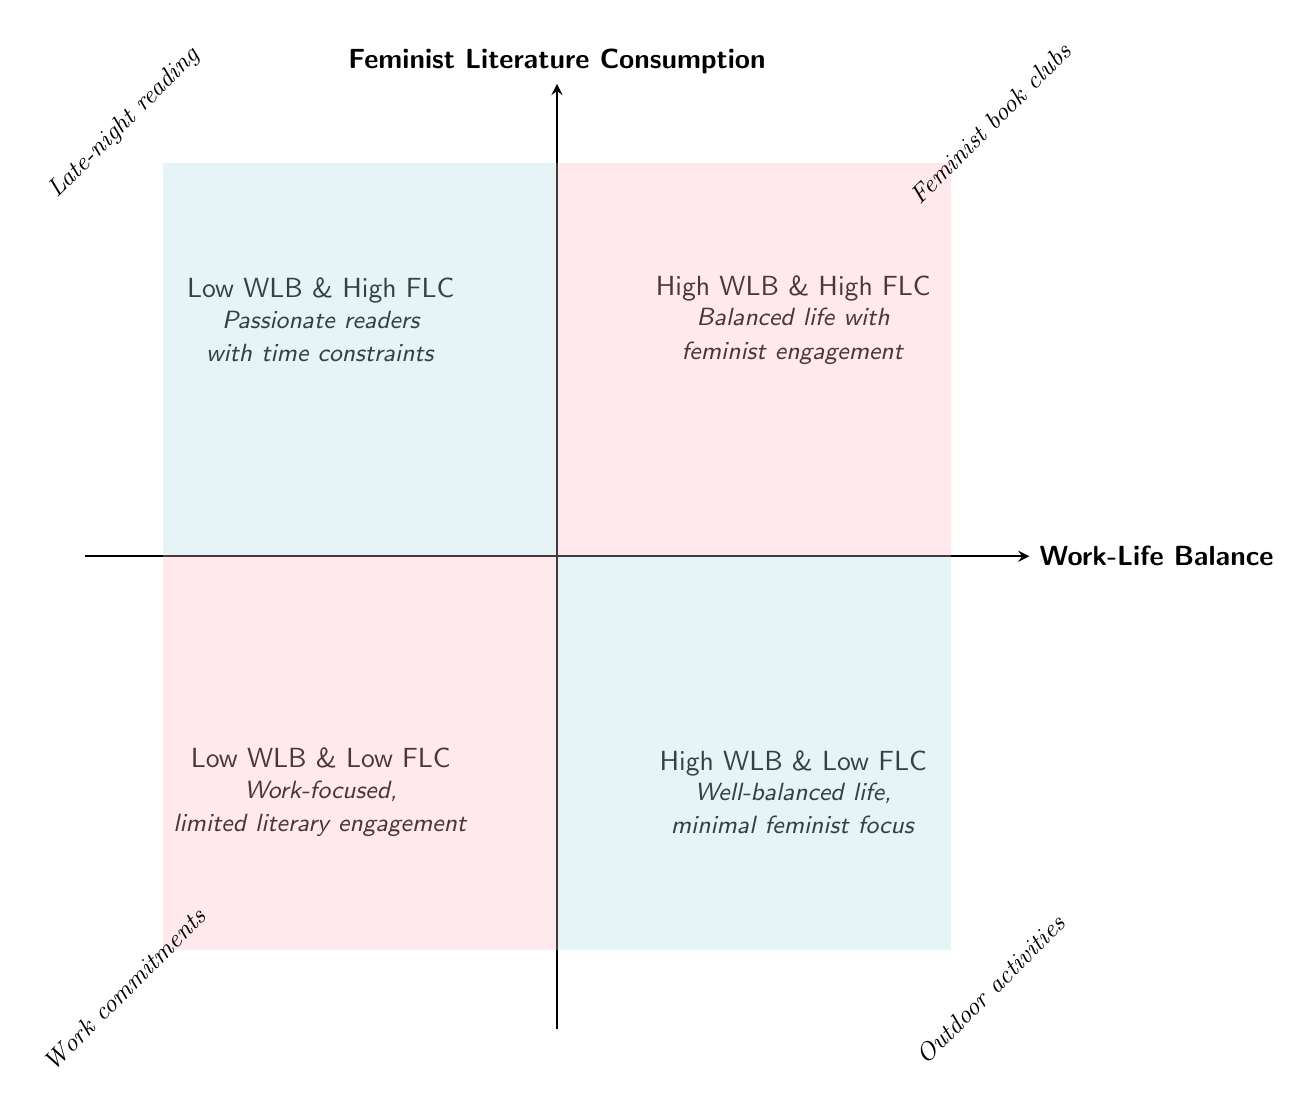What quadrant represents individuals with both high work-life balance and high feminist literature consumption? The top right quadrant represents individuals who are engaged in both aspects—high work-life balance and high feminist literature consumption.
Answer: High WLB & High FLC How many quadrants are represented in this diagram? The diagram is divided into four distinct quadrants, each depicting different combinations of work-life balance and feminist literature consumption.
Answer: Four What is a characteristic of individuals in the low work-life balance and high feminist literature consumption quadrant? Individuals in this quadrant often read feminist literature late at night, indicating they prioritize feminist literature despite poor work-life balance.
Answer: Late-night reading Which quadrant describes individuals who have minimal engagement with feminist literature? The bottom left quadrant indicates individuals struggle with work-life balance and show low engagement with feminist literature.
Answer: Low WLB & Low FLC What describes the lifestyle of people with high work-life balance but low feminist literature consumption? People in this quadrant enjoy a balance in their lives but do not prioritize feminist literature, often choosing mainstream interests instead.
Answer: Well-balanced life, minimal feminist focus Which quadrant features passionate readers who may struggle with time management? The top left quadrant portrays individuals who are committed to feminist literature but have difficulty managing their personal and professional commitments.
Answer: Low WLB & High FLC How do individuals in the high work-life balance and low feminist literature consumption quadrant prioritize their time? Individuals prioritize general interests and work over engaging with feminist literature, focusing on outdoor activities and other non-feminist content.
Answer: Outdoor activities What is a common activity for people in the low work-life balance and low feminist literature consumption quadrant? Individuals in this quadrant are often caught up in work commitments that limit their leisure reading, indicating minimal engagement with literature.
Answer: Work commitments 